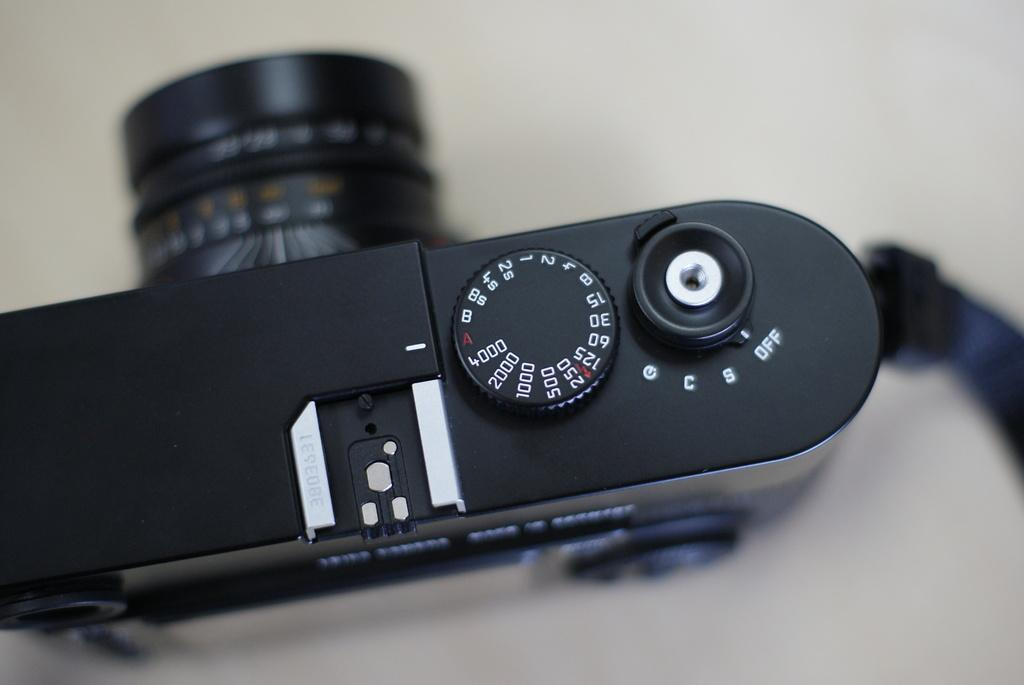What object is the main subject of the image? There is a camera in the image. What can be said about the color of the camera? The camera is black in color. What type of animals can be seen at the zoo in the image? There is no zoo or animals present in the image; it features a black camera. What error message is displayed on the camera in the image? There is no error message displayed on the camera in the image; it is simply a black camera. 